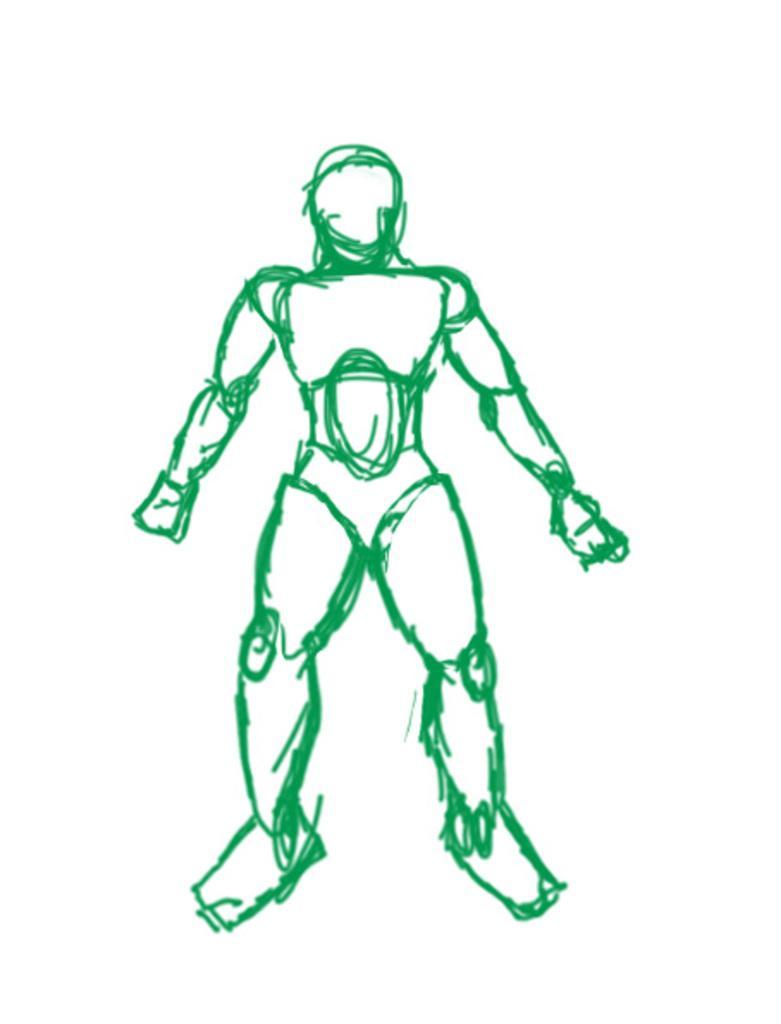Describe this image in one or two sentences. The picture consists of a drawing. The drawing is in green color. It is looking like an iron man. 